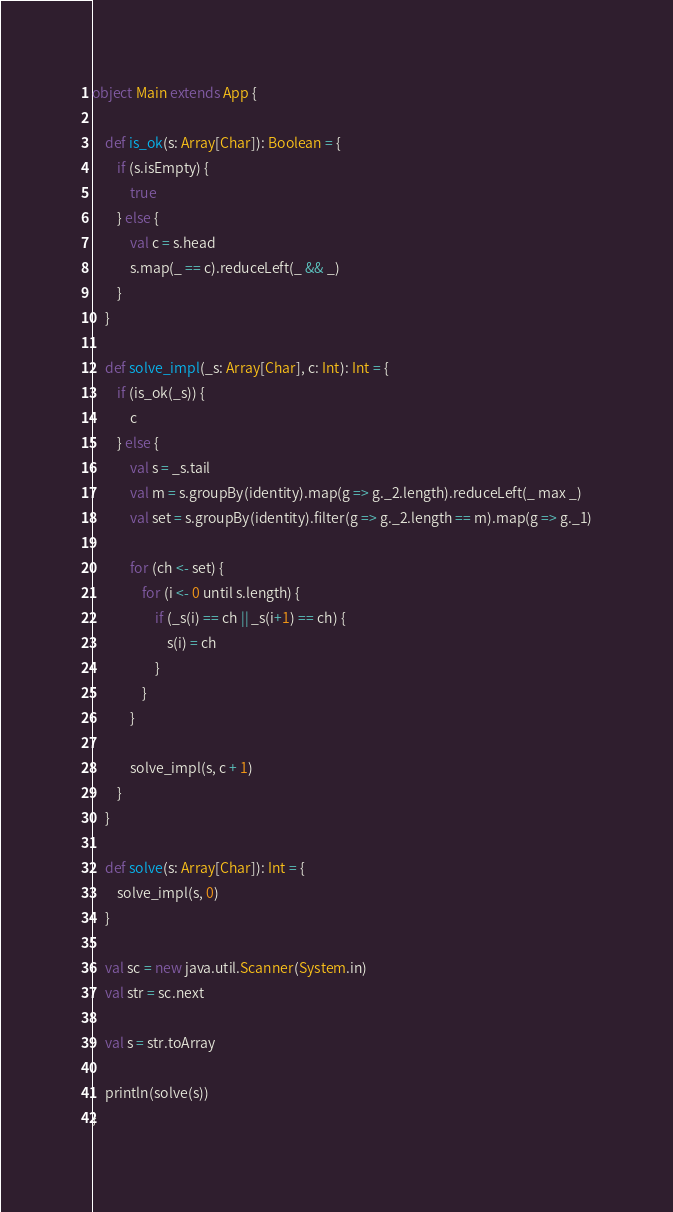Convert code to text. <code><loc_0><loc_0><loc_500><loc_500><_Scala_>
object Main extends App {
    
    def is_ok(s: Array[Char]): Boolean = {
        if (s.isEmpty) {
            true
        } else {
            val c = s.head
            s.map(_ == c).reduceLeft(_ && _)
        }
    }
    
    def solve_impl(_s: Array[Char], c: Int): Int = {
        if (is_ok(_s)) {
            c
        } else {
            val s = _s.tail
            val m = s.groupBy(identity).map(g => g._2.length).reduceLeft(_ max _)
            val set = s.groupBy(identity).filter(g => g._2.length == m).map(g => g._1)
            
            for (ch <- set) {
                for (i <- 0 until s.length) {
                    if (_s(i) == ch || _s(i+1) == ch) {
                        s(i) = ch
                    }
                }
            }
            
            solve_impl(s, c + 1)
        }
    }
    
    def solve(s: Array[Char]): Int = {
        solve_impl(s, 0)
    }
    
    val sc = new java.util.Scanner(System.in)
    val str = sc.next
    
    val s = str.toArray
    
    println(solve(s))
}</code> 